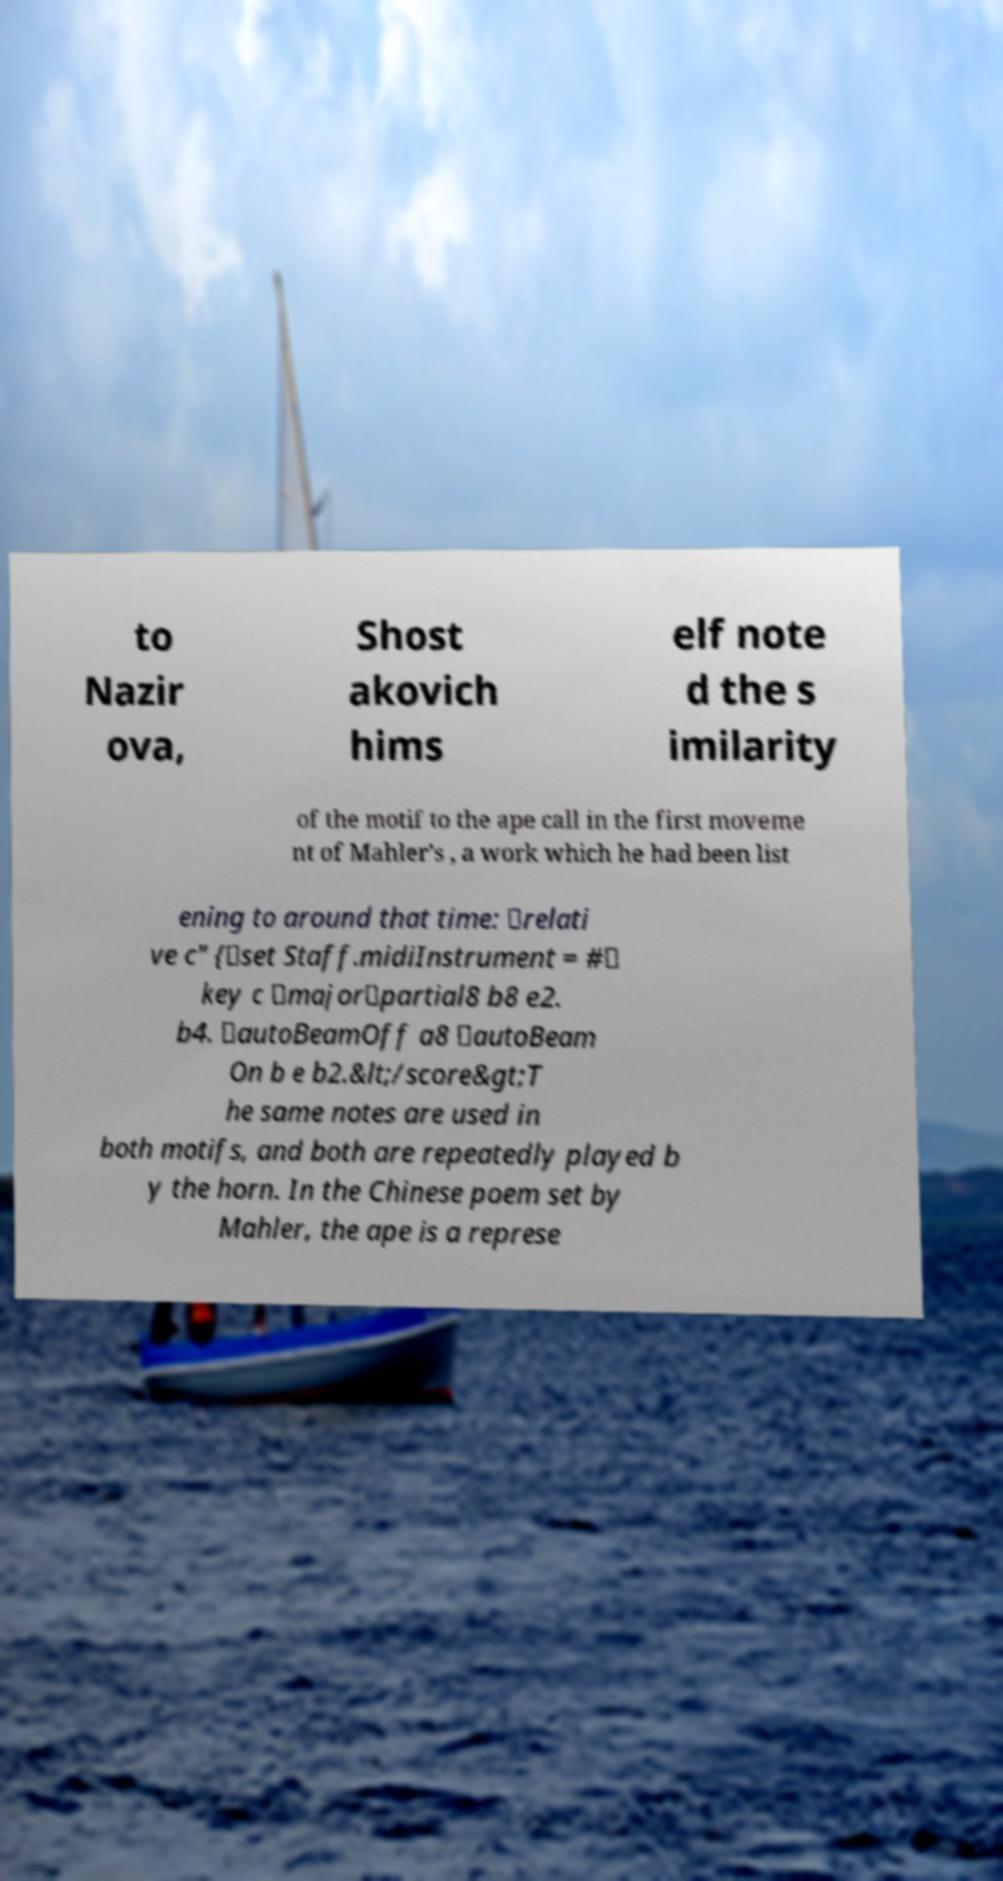For documentation purposes, I need the text within this image transcribed. Could you provide that? to Nazir ova, Shost akovich hims elf note d the s imilarity of the motif to the ape call in the first moveme nt of Mahler's , a work which he had been list ening to around that time: \relati ve c" {\set Staff.midiInstrument = #\ key c \major\partial8 b8 e2. b4. \autoBeamOff a8 \autoBeam On b e b2.&lt;/score&gt;T he same notes are used in both motifs, and both are repeatedly played b y the horn. In the Chinese poem set by Mahler, the ape is a represe 